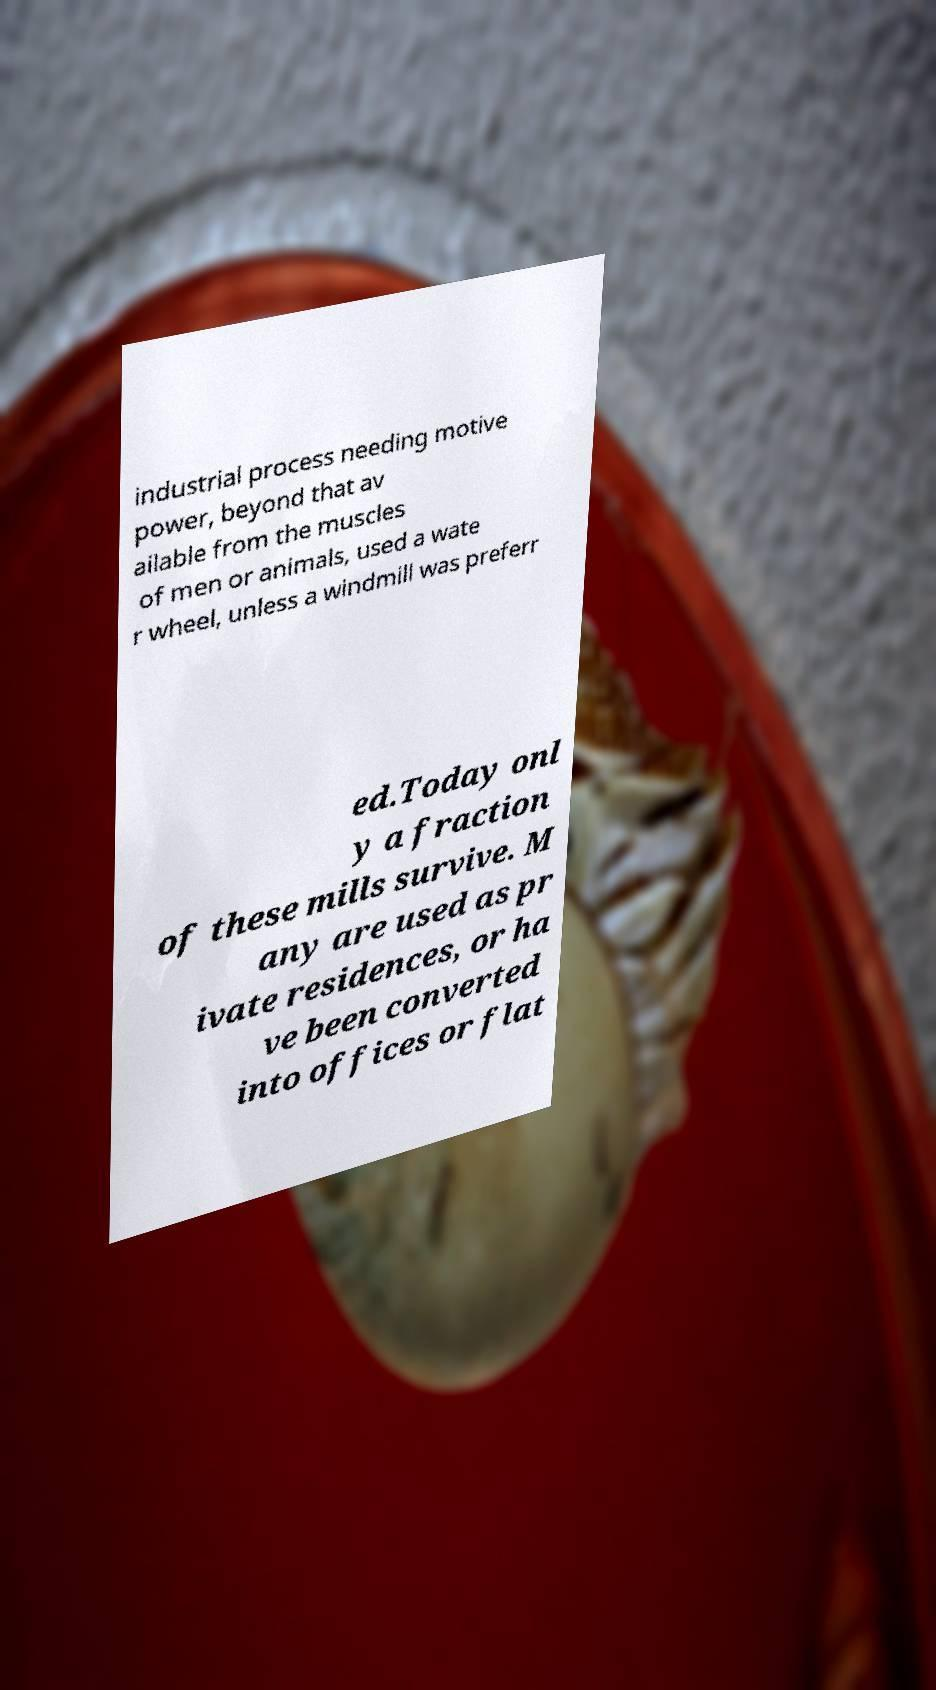Please read and relay the text visible in this image. What does it say? industrial process needing motive power, beyond that av ailable from the muscles of men or animals, used a wate r wheel, unless a windmill was preferr ed.Today onl y a fraction of these mills survive. M any are used as pr ivate residences, or ha ve been converted into offices or flat 